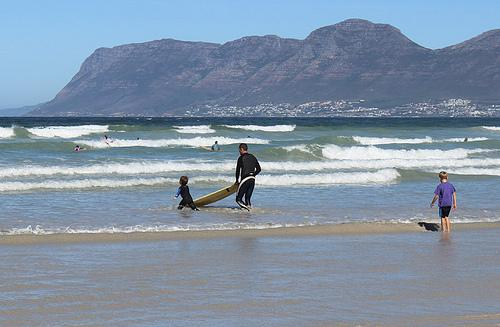Question: where was this picture taken?
Choices:
A. At the beach.
B. On the couch.
C. At my house.
D. In the park.
Answer with the letter. Answer: A Question: what color is the sky?
Choices:
A. Purple.
B. Blue.
C. Yellow.
D. Orange.
Answer with the letter. Answer: B Question: what color is the sand?
Choices:
A. Yellow.
B. Brown.
C. White.
D. Black.
Answer with the letter. Answer: B Question: how many people are the in this picture?
Choices:
A. 5.
B. 4.
C. 9.
D. 1.
Answer with the letter. Answer: C Question: what are these people doing?
Choices:
A. Swimming and surfing.
B. Playing a game.
C. Lauging.
D. Having fun.
Answer with the letter. Answer: A Question: what is in the background?
Choices:
A. Mountains.
B. Trees.
C. Ocean.
D. Flowers.
Answer with the letter. Answer: A Question: where are these people?
Choices:
A. At a beach.
B. In the store.
C. On the street.
D. At a party.
Answer with the letter. Answer: A 